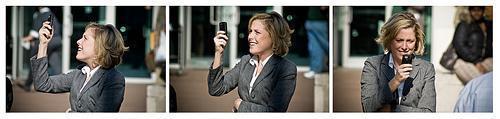How many photos of the woman?
Give a very brief answer. 3. 